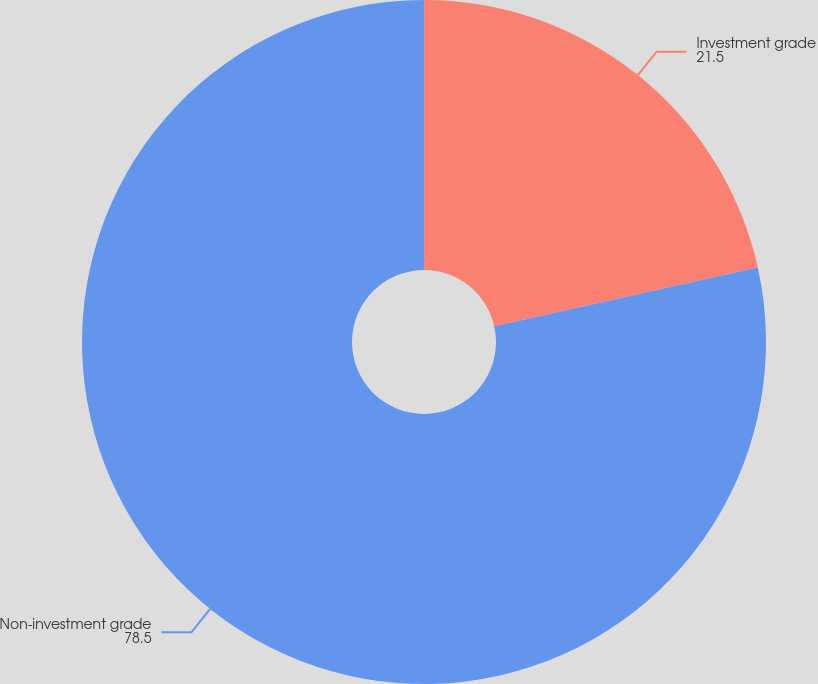<chart> <loc_0><loc_0><loc_500><loc_500><pie_chart><fcel>Investment grade<fcel>Non-investment grade<nl><fcel>21.5%<fcel>78.5%<nl></chart> 